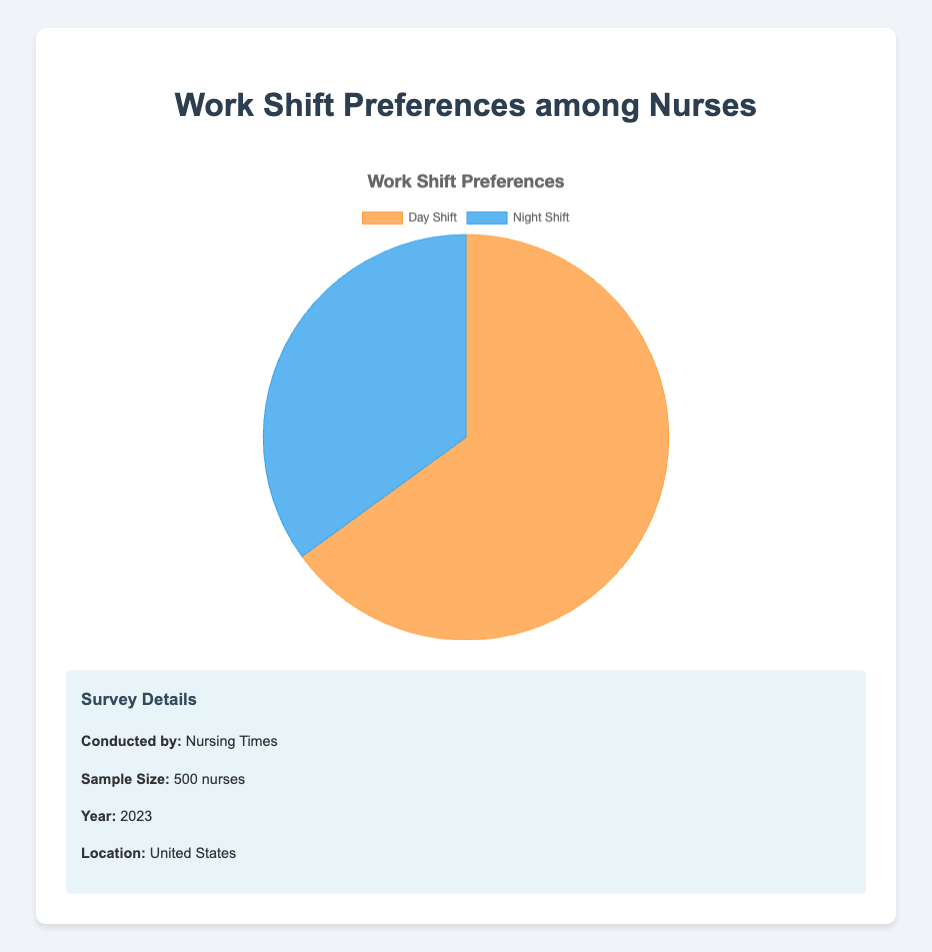What percentage of nurses prefer the day shift? In the pie chart, observe the segment labeled "Day Shift," which shows a percentage of 65%.
Answer: 65% What percentage of nurses prefer the night shift? In the pie chart, observe the segment labeled "Night Shift," which shows a percentage of 35%.
Answer: 35% Which shift has a higher preference among nurses? Compare the percentages shown in the pie chart. The day shift has 65%, and the night shift has 35%. Therefore, the day shift has a higher preference.
Answer: Day shift What is the difference in preference percentage between the day shift and night shift? Subtract the night shift percentage (35%) from the day shift percentage (65%). The calculation is 65% - 35% = 30%.
Answer: 30% How many more nurses prefer the day shift compared to the night shift, if the survey sampled 500 nurses? First, find the number of nurses who prefer each shift: 65% of 500 for the day shift (0.65 * 500 = 325), and 35% of 500 for the night shift (0.35 * 500 = 175). Then, subtract the night shift number from the day shift number: 325 - 175 = 150.
Answer: 150 Which section of the pie chart is larger, the one representing the day shift or the night shift? Observe the pie chart segments. The segment for the day shift covers a larger area than the segment for the night shift.
Answer: Day shift If the total number of nurses preferring either shift is 500, how many nurses prefer the night shift? Calculate 35% of 500 nurses: \( 0.35 \times 500 = 175 \).
Answer: 175 What are the colors representing the day shift and night shift in the pie chart? Observe the pie chart: The day shift is represented by an orange color, and the night shift is represented by a blue color.
Answer: Orange for day shift, blue for night shift If the survey were conducted again with a larger sample size, do you think the proportions would change significantly? Provide reasoning based on the current data shown. Based on the current data showing 65% preference for day shift and 35% for night shift, if the sample size is large enough and representative, it's likely that the proportions would remain roughly similar, but some variation is always possible due to random sampling errors and changing preferences.
Answer: Proportions could remain similar but some variation is possible Does the pie chart indicate any specific reasoning behind nurses' shift preferences? The pie chart only provides the percentage preference for day and night shifts but does not include any information or reasoning behind those preferences. Additional qualitative data would be required for such insights.
Answer: No 